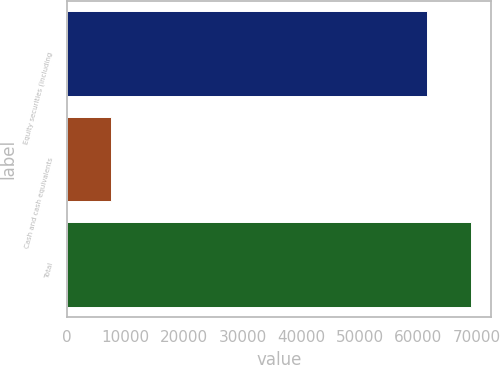Convert chart. <chart><loc_0><loc_0><loc_500><loc_500><bar_chart><fcel>Equity securities (including<fcel>Cash and cash equivalents<fcel>Total<nl><fcel>61472<fcel>7516<fcel>68988<nl></chart> 